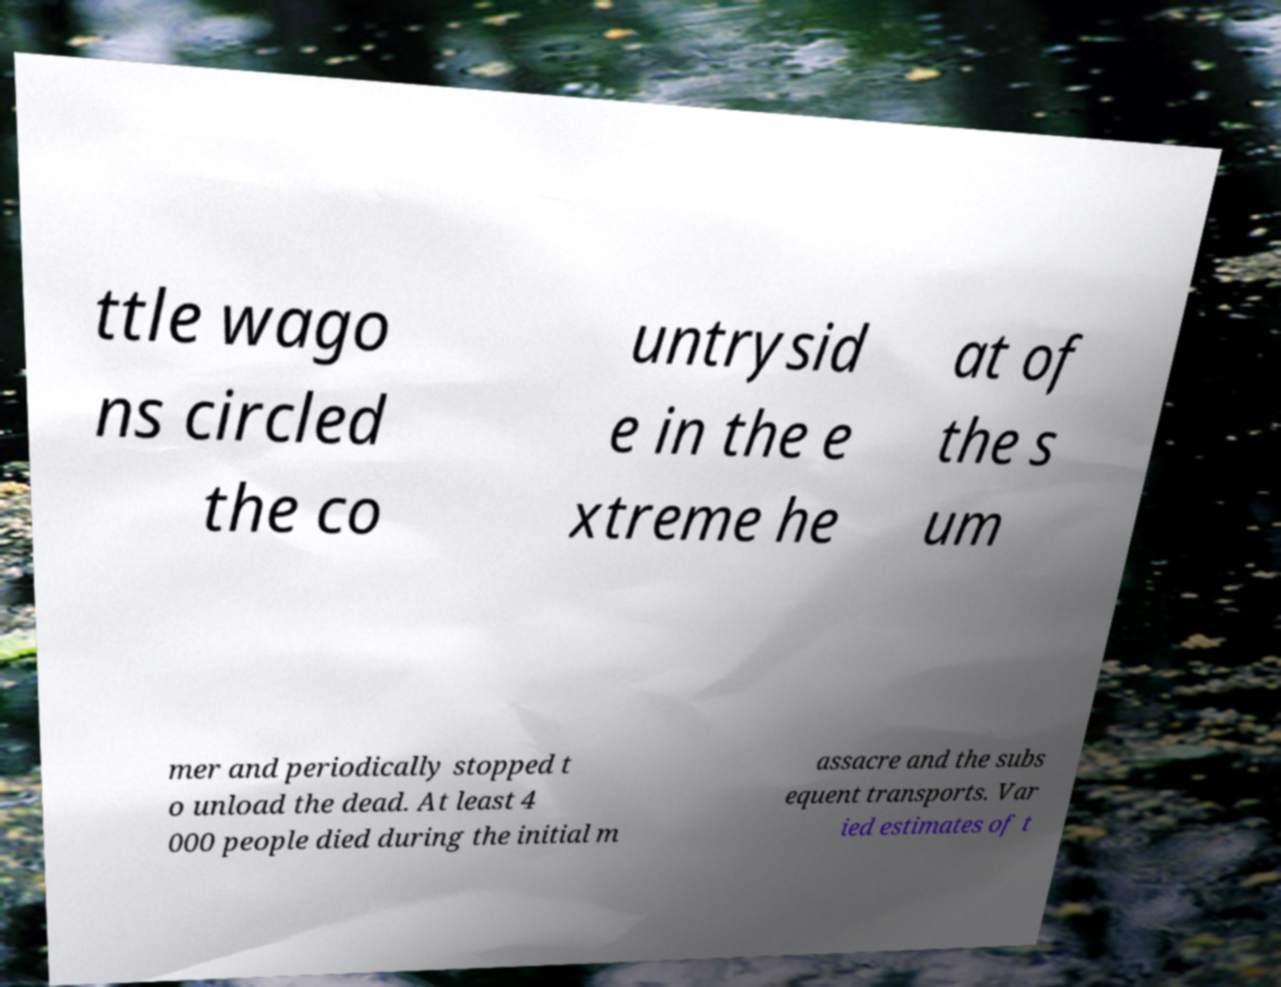Please identify and transcribe the text found in this image. ttle wago ns circled the co untrysid e in the e xtreme he at of the s um mer and periodically stopped t o unload the dead. At least 4 000 people died during the initial m assacre and the subs equent transports. Var ied estimates of t 